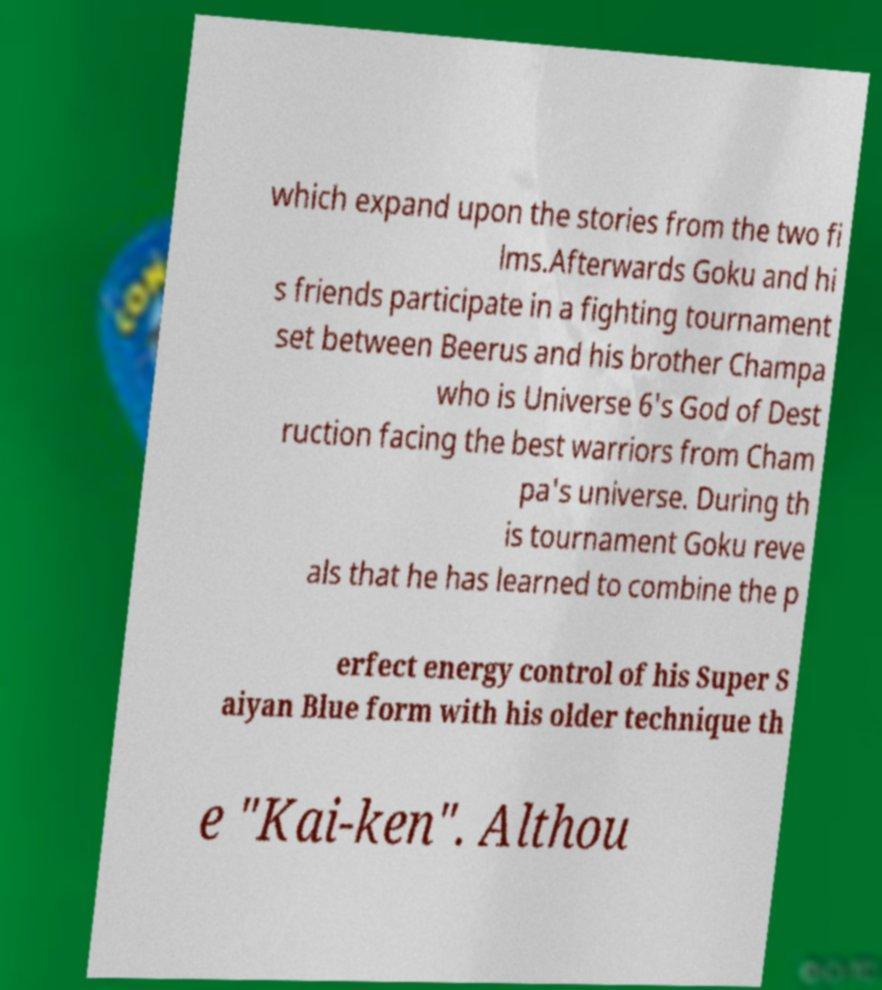There's text embedded in this image that I need extracted. Can you transcribe it verbatim? which expand upon the stories from the two fi lms.Afterwards Goku and hi s friends participate in a fighting tournament set between Beerus and his brother Champa who is Universe 6's God of Dest ruction facing the best warriors from Cham pa's universe. During th is tournament Goku reve als that he has learned to combine the p erfect energy control of his Super S aiyan Blue form with his older technique th e "Kai-ken". Althou 